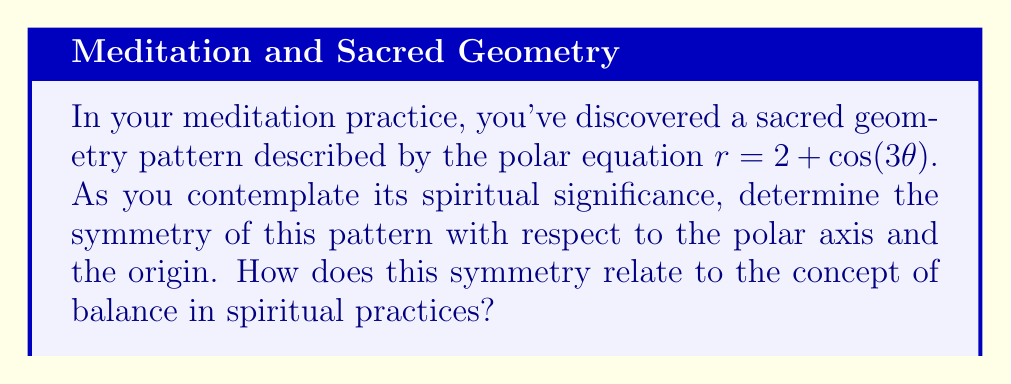Teach me how to tackle this problem. To determine the symmetry of the given polar equation $r = 2 + \cos(3\theta)$, we need to examine its behavior under certain transformations:

1. Symmetry about the polar axis:
   To check for symmetry about the polar axis, we replace $\theta$ with $-\theta$:
   $r = 2 + \cos(3(-\theta)) = 2 + \cos(-3\theta) = 2 + \cos(3\theta)$
   The equation remains unchanged, indicating symmetry about the polar axis.

2. Symmetry about the origin:
   To check for symmetry about the origin, we replace $r$ with $-r$ and $\theta$ with $\theta + \pi$:
   $-r = 2 + \cos(3(\theta + \pi))$
   $-r = 2 + \cos(3\theta + 3\pi) = 2 + \cos(3\theta)$
   This does not yield the original equation, so there is no symmetry about the origin.

3. Rotational symmetry:
   The presence of $\cos(3\theta)$ in the equation suggests 3-fold rotational symmetry. To verify:
   $r = 2 + \cos(3(\theta + \frac{2\pi}{3}))$
   $= 2 + \cos(3\theta + 2\pi) = 2 + \cos(3\theta)$
   The equation remains unchanged when rotated by $\frac{2\pi}{3}$, confirming 3-fold rotational symmetry.

[asy]
import graph;
size(200);
real r(real t) {return 2+cos(3*t);}
draw(polargraph(r,0,2*pi,300),blue);
draw(circle((0,0),2),dashed);
draw((0,0)--(3,0),arrow=Arrow(TeXHead));
draw((0,0)--(0,3),arrow=Arrow(TeXHead));
label("$x$",(3.2,0));
label("$y$",(0,3.2));
[/asy]

The symmetry of this sacred geometry pattern reflects balance in spiritual practices:
1. Symmetry about the polar axis represents the duality of spiritual and material realms.
2. 3-fold rotational symmetry symbolizes the trinity or threefold nature present in many spiritual traditions.
3. The absence of symmetry about the origin suggests the importance of a central point or source in spiritual growth.
Answer: The sacred geometry pattern has symmetry about the polar axis and 3-fold rotational symmetry, but no symmetry about the origin. This symmetry represents balance between duality, trinity concepts, and the importance of a central spiritual source. 